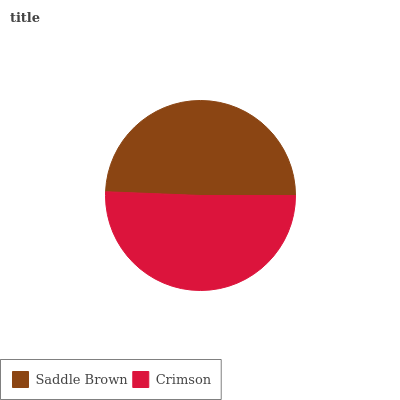Is Saddle Brown the minimum?
Answer yes or no. Yes. Is Crimson the maximum?
Answer yes or no. Yes. Is Crimson the minimum?
Answer yes or no. No. Is Crimson greater than Saddle Brown?
Answer yes or no. Yes. Is Saddle Brown less than Crimson?
Answer yes or no. Yes. Is Saddle Brown greater than Crimson?
Answer yes or no. No. Is Crimson less than Saddle Brown?
Answer yes or no. No. Is Crimson the high median?
Answer yes or no. Yes. Is Saddle Brown the low median?
Answer yes or no. Yes. Is Saddle Brown the high median?
Answer yes or no. No. Is Crimson the low median?
Answer yes or no. No. 